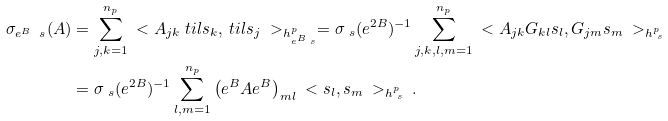Convert formula to latex. <formula><loc_0><loc_0><loc_500><loc_500>\sigma _ { e ^ { B } \ s } ( A ) & = \sum _ { j , k = 1 } ^ { n _ { p } } \ < A _ { j k } \ t i l { s } _ { k } , \ t i l { s } _ { j } \ > _ { h ^ { p } _ { e ^ { B } \ s } } = \sigma _ { \ s } ( e ^ { 2 B } ) ^ { - 1 } \sum _ { j , k , l , m = 1 } ^ { n _ { p } } \ < A _ { j k } G _ { k l } s _ { l } , G _ { j m } s _ { m } \ > _ { h ^ { p } _ { \ s } } \\ & = \sigma _ { \ s } ( e ^ { 2 B } ) ^ { - 1 } \sum _ { l , m = 1 } ^ { n _ { p } } \left ( e ^ { B } A e ^ { B } \right ) _ { m l } \ < s _ { l } , s _ { m } \ > _ { h ^ { p } _ { \ s } } \, .</formula> 